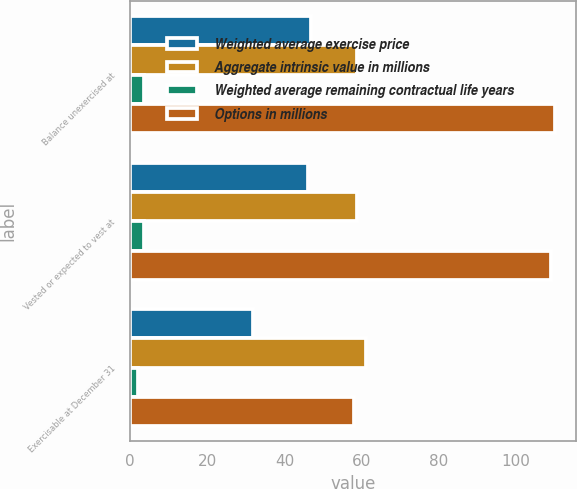Convert chart. <chart><loc_0><loc_0><loc_500><loc_500><stacked_bar_chart><ecel><fcel>Balance unexercised at<fcel>Vested or expected to vest at<fcel>Exercisable at December 31<nl><fcel>Weighted average exercise price<fcel>46.8<fcel>46<fcel>31.7<nl><fcel>Aggregate intrinsic value in millions<fcel>58.66<fcel>58.71<fcel>61.05<nl><fcel>Weighted average remaining contractual life years<fcel>3.6<fcel>3.5<fcel>2.1<nl><fcel>Options in millions<fcel>110<fcel>109<fcel>58<nl></chart> 